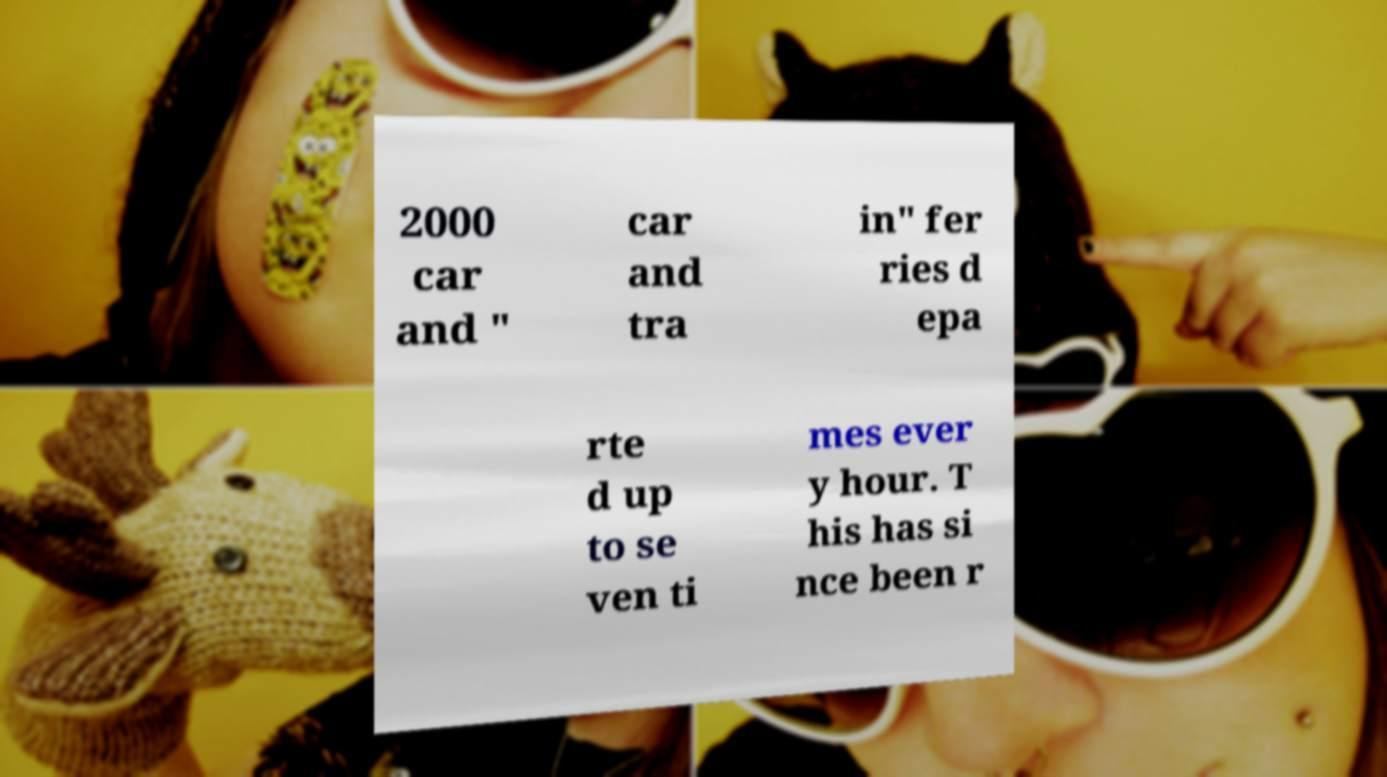Please identify and transcribe the text found in this image. 2000 car and " car and tra in" fer ries d epa rte d up to se ven ti mes ever y hour. T his has si nce been r 